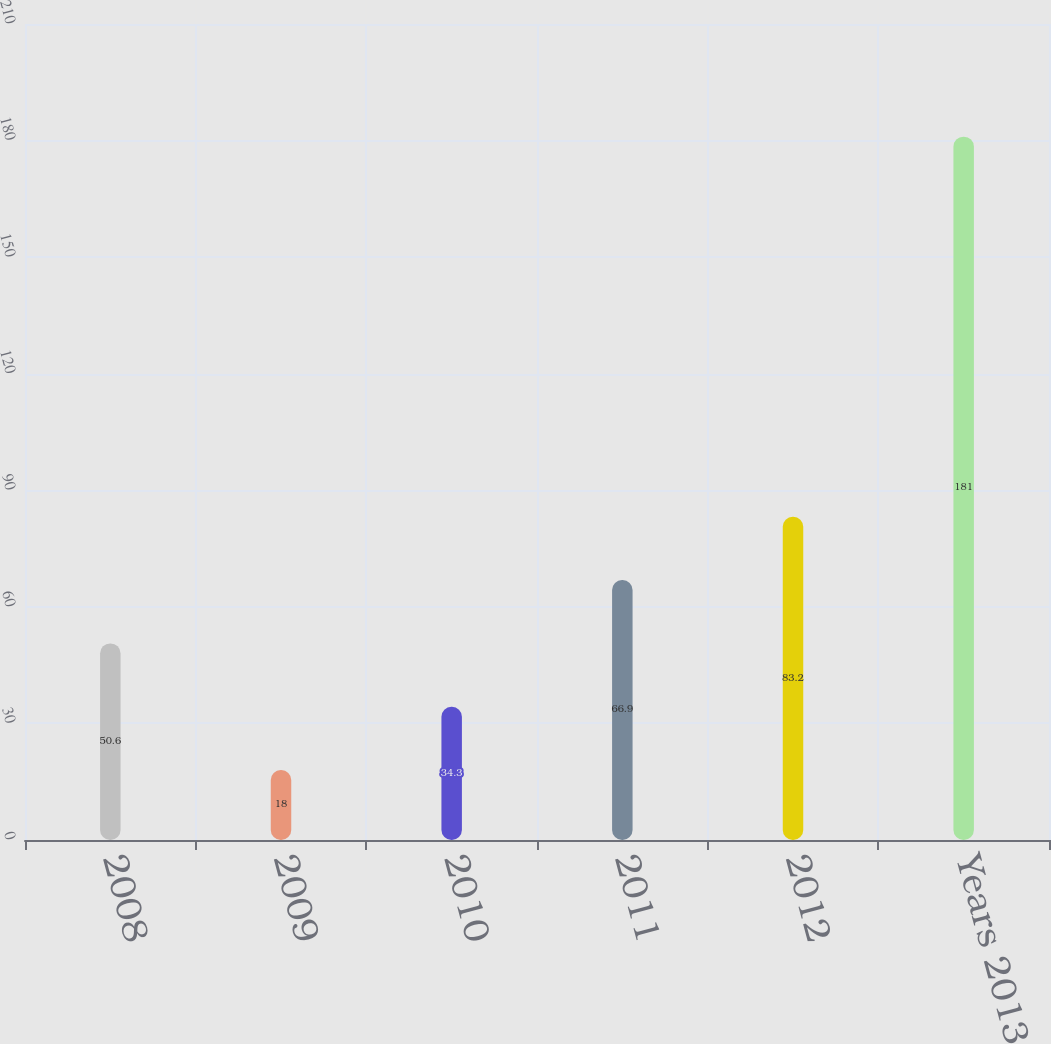<chart> <loc_0><loc_0><loc_500><loc_500><bar_chart><fcel>2008<fcel>2009<fcel>2010<fcel>2011<fcel>2012<fcel>Years 2013 - 2017<nl><fcel>50.6<fcel>18<fcel>34.3<fcel>66.9<fcel>83.2<fcel>181<nl></chart> 